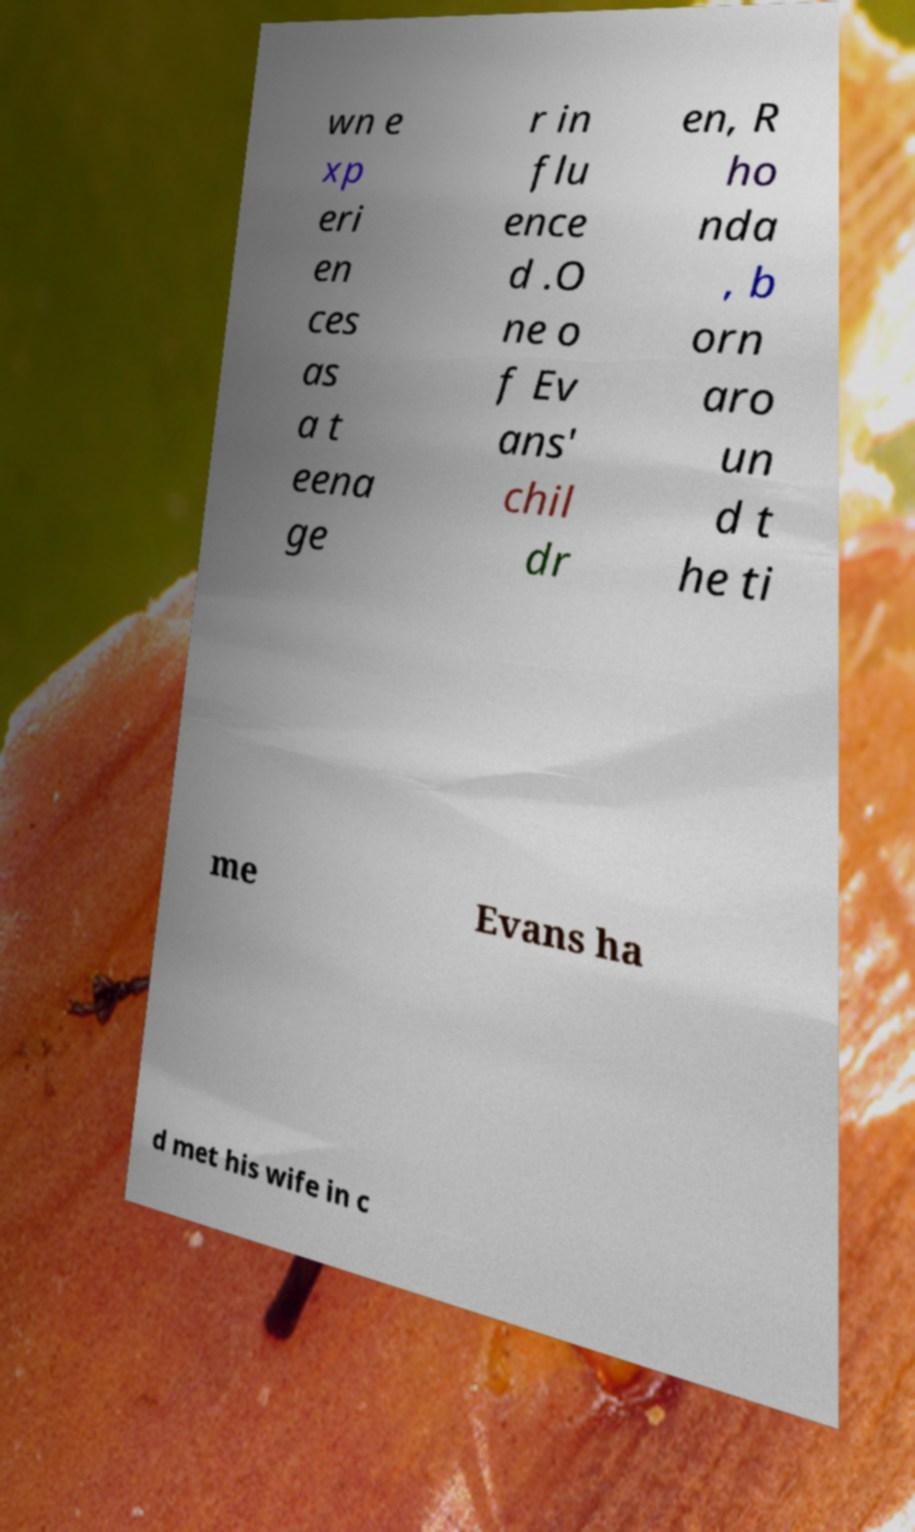Can you accurately transcribe the text from the provided image for me? wn e xp eri en ces as a t eena ge r in flu ence d .O ne o f Ev ans' chil dr en, R ho nda , b orn aro un d t he ti me Evans ha d met his wife in c 